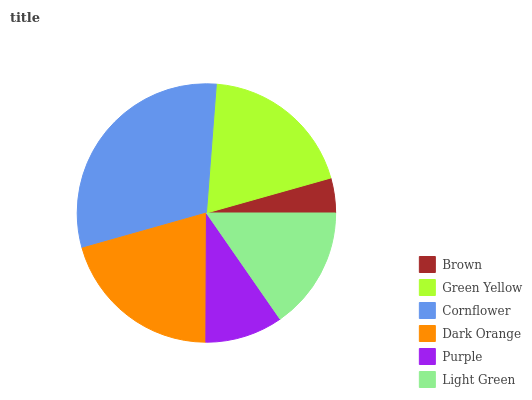Is Brown the minimum?
Answer yes or no. Yes. Is Cornflower the maximum?
Answer yes or no. Yes. Is Green Yellow the minimum?
Answer yes or no. No. Is Green Yellow the maximum?
Answer yes or no. No. Is Green Yellow greater than Brown?
Answer yes or no. Yes. Is Brown less than Green Yellow?
Answer yes or no. Yes. Is Brown greater than Green Yellow?
Answer yes or no. No. Is Green Yellow less than Brown?
Answer yes or no. No. Is Green Yellow the high median?
Answer yes or no. Yes. Is Light Green the low median?
Answer yes or no. Yes. Is Dark Orange the high median?
Answer yes or no. No. Is Purple the low median?
Answer yes or no. No. 